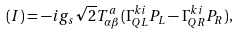Convert formula to latex. <formula><loc_0><loc_0><loc_500><loc_500>( I ) = - i g _ { s } \sqrt { 2 } T ^ { a } _ { \alpha \beta } ( \Gamma _ { Q L } ^ { k i } P _ { L } - \Gamma _ { Q R } ^ { k i } P _ { R } ) ,</formula> 